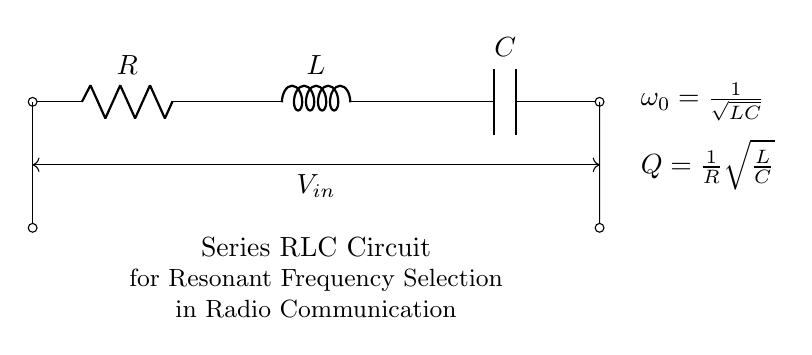What components are in the circuit? The circuit contains a resistor, an inductor, and a capacitor arranged in series.
Answer: Resistor, Inductor, Capacitor What is the expression for the resonant frequency? The resonant frequency is determined by the formula derived from the circuit design, which is defined as the reciprocal of the square root of the product of inductance and capacitance.
Answer: One over the square root of LC What is the role of the resistor in the circuit? The resistor influences the damping of the oscillations and affects the quality factor of the circuit, determining how quickly the circuit responds to the input signal.
Answer: Influence damping What does the term "Q" represent? "Q" represents the quality factor, which indicates the sharpness of the resonance peak; it is defined as one over the resistance multiplied by the square root of inductance divided by capacitance.
Answer: Quality factor How are the components connected? The resistor, inductor, and capacitor are connected in series, meaning the current flows through each component one after the other without any branching.
Answer: In series What happens to the resonance when resistance increases? An increase in resistance leads to a lower quality factor, indicating a broader resonance peak, which can affect the circuit's ability to select specific frequencies.
Answer: Broadened resonance peak What does "Vin" represent in the circuit? "Vin" represents the input voltage applied across the entire series combination of the resistor, inductor, and capacitor.
Answer: Input voltage 